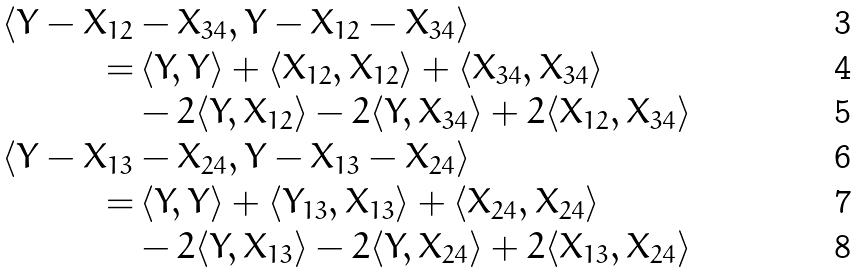<formula> <loc_0><loc_0><loc_500><loc_500>\langle Y - X _ { 1 2 } & - X _ { 3 4 } , Y - X _ { 1 2 } - X _ { 3 4 } \rangle \\ = & \, \langle Y , Y \rangle + \langle X _ { 1 2 } , X _ { 1 2 } \rangle + \langle X _ { 3 4 } , X _ { 3 4 } \rangle \\ & - 2 \langle Y , X _ { 1 2 } \rangle - 2 \langle Y , X _ { 3 4 } \rangle + 2 \langle X _ { 1 2 } , X _ { 3 4 } \rangle \\ \langle Y - X _ { 1 3 } & - X _ { 2 4 } , Y - X _ { 1 3 } - X _ { 2 4 } \rangle \\ = & \, \langle Y , Y \rangle + \langle Y _ { 1 3 } , X _ { 1 3 } \rangle + \langle X _ { 2 4 } , X _ { 2 4 } \rangle \\ & - 2 \langle Y , X _ { 1 3 } \rangle - 2 \langle Y , X _ { 2 4 } \rangle + 2 \langle X _ { 1 3 } , X _ { 2 4 } \rangle</formula> 